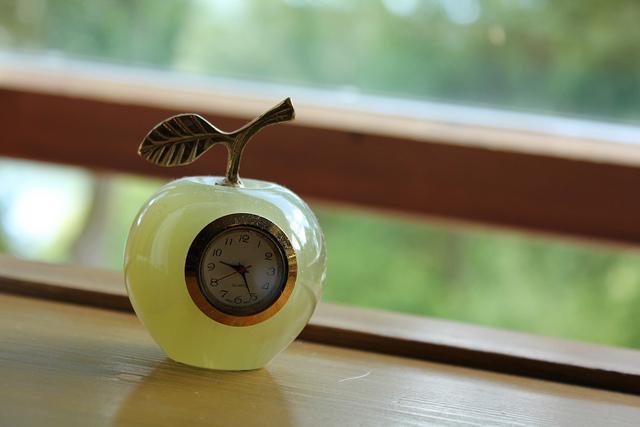How many people in the picture?
Give a very brief answer. 0. 